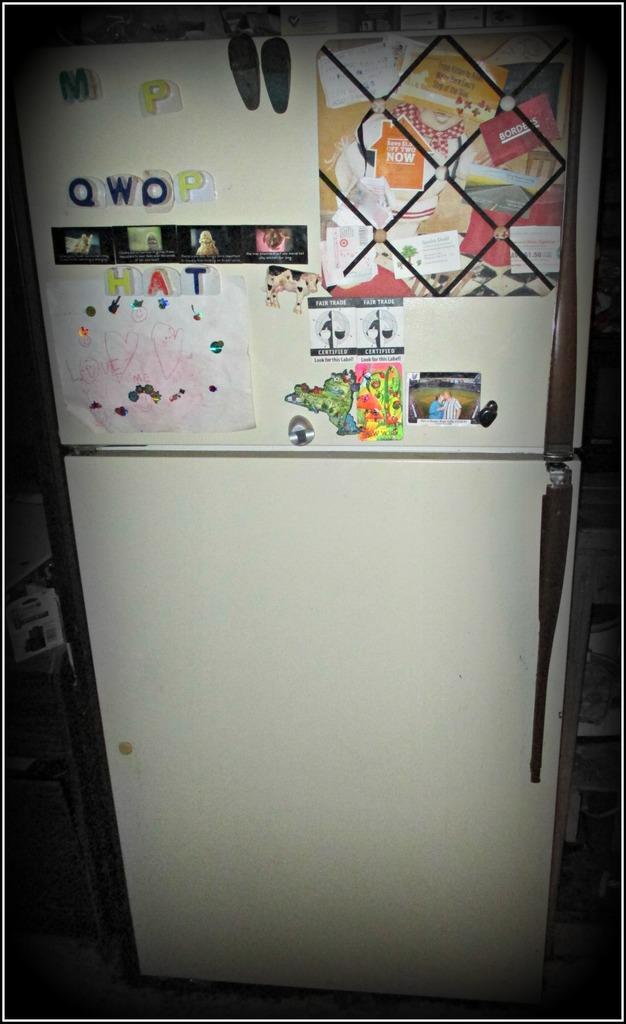Can you describe this image briefly? In this image I can see a refrigerator. I can see few papers and posters on it. 